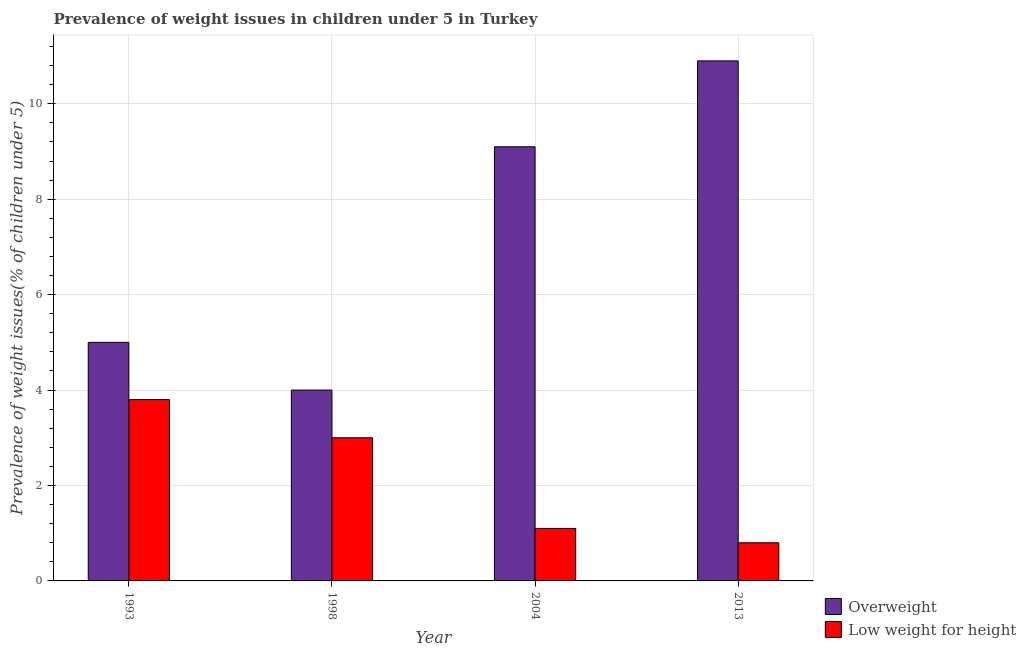How many groups of bars are there?
Ensure brevity in your answer.  4. Are the number of bars per tick equal to the number of legend labels?
Your answer should be very brief. Yes. Are the number of bars on each tick of the X-axis equal?
Ensure brevity in your answer.  Yes. How many bars are there on the 3rd tick from the right?
Keep it short and to the point. 2. What is the label of the 3rd group of bars from the left?
Provide a short and direct response. 2004. In how many cases, is the number of bars for a given year not equal to the number of legend labels?
Offer a terse response. 0. What is the percentage of underweight children in 1993?
Give a very brief answer. 3.8. Across all years, what is the maximum percentage of underweight children?
Your answer should be compact. 3.8. Across all years, what is the minimum percentage of underweight children?
Your response must be concise. 0.8. What is the total percentage of overweight children in the graph?
Ensure brevity in your answer.  29. What is the difference between the percentage of underweight children in 1998 and that in 2004?
Offer a very short reply. 1.9. What is the difference between the percentage of overweight children in 2013 and the percentage of underweight children in 2004?
Your answer should be compact. 1.8. What is the average percentage of overweight children per year?
Your response must be concise. 7.25. What is the ratio of the percentage of underweight children in 1993 to that in 2004?
Your answer should be very brief. 3.45. Is the percentage of underweight children in 1998 less than that in 2004?
Offer a very short reply. No. What is the difference between the highest and the second highest percentage of overweight children?
Keep it short and to the point. 1.8. What is the difference between the highest and the lowest percentage of underweight children?
Your answer should be compact. 3. In how many years, is the percentage of overweight children greater than the average percentage of overweight children taken over all years?
Provide a succinct answer. 2. What does the 1st bar from the left in 1993 represents?
Provide a short and direct response. Overweight. What does the 1st bar from the right in 2004 represents?
Your response must be concise. Low weight for height. How many bars are there?
Your answer should be very brief. 8. How many years are there in the graph?
Keep it short and to the point. 4. What is the difference between two consecutive major ticks on the Y-axis?
Your response must be concise. 2. Does the graph contain any zero values?
Ensure brevity in your answer.  No. Does the graph contain grids?
Keep it short and to the point. Yes. Where does the legend appear in the graph?
Your response must be concise. Bottom right. How many legend labels are there?
Your answer should be very brief. 2. What is the title of the graph?
Your answer should be very brief. Prevalence of weight issues in children under 5 in Turkey. What is the label or title of the X-axis?
Your response must be concise. Year. What is the label or title of the Y-axis?
Keep it short and to the point. Prevalence of weight issues(% of children under 5). What is the Prevalence of weight issues(% of children under 5) of Low weight for height in 1993?
Your answer should be compact. 3.8. What is the Prevalence of weight issues(% of children under 5) in Low weight for height in 1998?
Offer a terse response. 3. What is the Prevalence of weight issues(% of children under 5) in Overweight in 2004?
Offer a very short reply. 9.1. What is the Prevalence of weight issues(% of children under 5) in Low weight for height in 2004?
Offer a very short reply. 1.1. What is the Prevalence of weight issues(% of children under 5) of Overweight in 2013?
Offer a terse response. 10.9. What is the Prevalence of weight issues(% of children under 5) of Low weight for height in 2013?
Keep it short and to the point. 0.8. Across all years, what is the maximum Prevalence of weight issues(% of children under 5) in Overweight?
Ensure brevity in your answer.  10.9. Across all years, what is the maximum Prevalence of weight issues(% of children under 5) of Low weight for height?
Your response must be concise. 3.8. Across all years, what is the minimum Prevalence of weight issues(% of children under 5) in Low weight for height?
Give a very brief answer. 0.8. What is the total Prevalence of weight issues(% of children under 5) in Low weight for height in the graph?
Your response must be concise. 8.7. What is the difference between the Prevalence of weight issues(% of children under 5) in Overweight in 1993 and that in 1998?
Offer a terse response. 1. What is the difference between the Prevalence of weight issues(% of children under 5) in Low weight for height in 1993 and that in 1998?
Make the answer very short. 0.8. What is the difference between the Prevalence of weight issues(% of children under 5) in Overweight in 1993 and that in 2004?
Give a very brief answer. -4.1. What is the difference between the Prevalence of weight issues(% of children under 5) in Low weight for height in 1993 and that in 2004?
Keep it short and to the point. 2.7. What is the difference between the Prevalence of weight issues(% of children under 5) of Overweight in 1993 and that in 2013?
Provide a succinct answer. -5.9. What is the difference between the Prevalence of weight issues(% of children under 5) in Low weight for height in 1998 and that in 2004?
Your response must be concise. 1.9. What is the difference between the Prevalence of weight issues(% of children under 5) of Overweight in 1998 and that in 2013?
Give a very brief answer. -6.9. What is the difference between the Prevalence of weight issues(% of children under 5) in Low weight for height in 1998 and that in 2013?
Keep it short and to the point. 2.2. What is the difference between the Prevalence of weight issues(% of children under 5) in Overweight in 2004 and that in 2013?
Provide a short and direct response. -1.8. What is the difference between the Prevalence of weight issues(% of children under 5) of Overweight in 1993 and the Prevalence of weight issues(% of children under 5) of Low weight for height in 1998?
Your answer should be very brief. 2. What is the difference between the Prevalence of weight issues(% of children under 5) in Overweight in 1998 and the Prevalence of weight issues(% of children under 5) in Low weight for height in 2004?
Ensure brevity in your answer.  2.9. What is the difference between the Prevalence of weight issues(% of children under 5) in Overweight in 1998 and the Prevalence of weight issues(% of children under 5) in Low weight for height in 2013?
Make the answer very short. 3.2. What is the difference between the Prevalence of weight issues(% of children under 5) of Overweight in 2004 and the Prevalence of weight issues(% of children under 5) of Low weight for height in 2013?
Provide a succinct answer. 8.3. What is the average Prevalence of weight issues(% of children under 5) in Overweight per year?
Provide a succinct answer. 7.25. What is the average Prevalence of weight issues(% of children under 5) of Low weight for height per year?
Keep it short and to the point. 2.17. In the year 1993, what is the difference between the Prevalence of weight issues(% of children under 5) of Overweight and Prevalence of weight issues(% of children under 5) of Low weight for height?
Provide a short and direct response. 1.2. In the year 2004, what is the difference between the Prevalence of weight issues(% of children under 5) in Overweight and Prevalence of weight issues(% of children under 5) in Low weight for height?
Keep it short and to the point. 8. What is the ratio of the Prevalence of weight issues(% of children under 5) in Overweight in 1993 to that in 1998?
Ensure brevity in your answer.  1.25. What is the ratio of the Prevalence of weight issues(% of children under 5) of Low weight for height in 1993 to that in 1998?
Give a very brief answer. 1.27. What is the ratio of the Prevalence of weight issues(% of children under 5) of Overweight in 1993 to that in 2004?
Make the answer very short. 0.55. What is the ratio of the Prevalence of weight issues(% of children under 5) of Low weight for height in 1993 to that in 2004?
Offer a terse response. 3.45. What is the ratio of the Prevalence of weight issues(% of children under 5) of Overweight in 1993 to that in 2013?
Your response must be concise. 0.46. What is the ratio of the Prevalence of weight issues(% of children under 5) of Low weight for height in 1993 to that in 2013?
Your answer should be compact. 4.75. What is the ratio of the Prevalence of weight issues(% of children under 5) in Overweight in 1998 to that in 2004?
Ensure brevity in your answer.  0.44. What is the ratio of the Prevalence of weight issues(% of children under 5) of Low weight for height in 1998 to that in 2004?
Your response must be concise. 2.73. What is the ratio of the Prevalence of weight issues(% of children under 5) in Overweight in 1998 to that in 2013?
Offer a very short reply. 0.37. What is the ratio of the Prevalence of weight issues(% of children under 5) of Low weight for height in 1998 to that in 2013?
Give a very brief answer. 3.75. What is the ratio of the Prevalence of weight issues(% of children under 5) in Overweight in 2004 to that in 2013?
Your answer should be compact. 0.83. What is the ratio of the Prevalence of weight issues(% of children under 5) in Low weight for height in 2004 to that in 2013?
Your response must be concise. 1.38. What is the difference between the highest and the second highest Prevalence of weight issues(% of children under 5) in Overweight?
Make the answer very short. 1.8. What is the difference between the highest and the lowest Prevalence of weight issues(% of children under 5) in Overweight?
Provide a short and direct response. 6.9. What is the difference between the highest and the lowest Prevalence of weight issues(% of children under 5) in Low weight for height?
Provide a succinct answer. 3. 